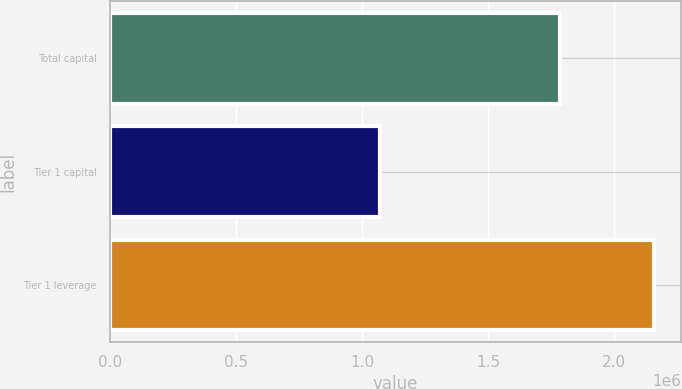<chart> <loc_0><loc_0><loc_500><loc_500><bar_chart><fcel>Total capital<fcel>Tier 1 capital<fcel>Tier 1 leverage<nl><fcel>1.7858e+06<fcel>1.07148e+06<fcel>2.15787e+06<nl></chart> 